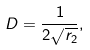Convert formula to latex. <formula><loc_0><loc_0><loc_500><loc_500>D = \frac { 1 } { 2 \sqrt { r _ { 2 } } } ,</formula> 